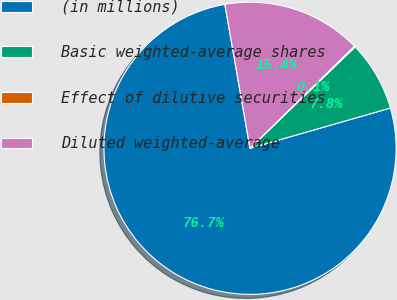Convert chart to OTSL. <chart><loc_0><loc_0><loc_500><loc_500><pie_chart><fcel>(in millions)<fcel>Basic weighted-average shares<fcel>Effect of dilutive securities<fcel>Diluted weighted-average<nl><fcel>76.7%<fcel>7.77%<fcel>0.11%<fcel>15.43%<nl></chart> 